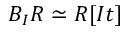<formula> <loc_0><loc_0><loc_500><loc_500>B _ { I } R \simeq R [ I t ]</formula> 